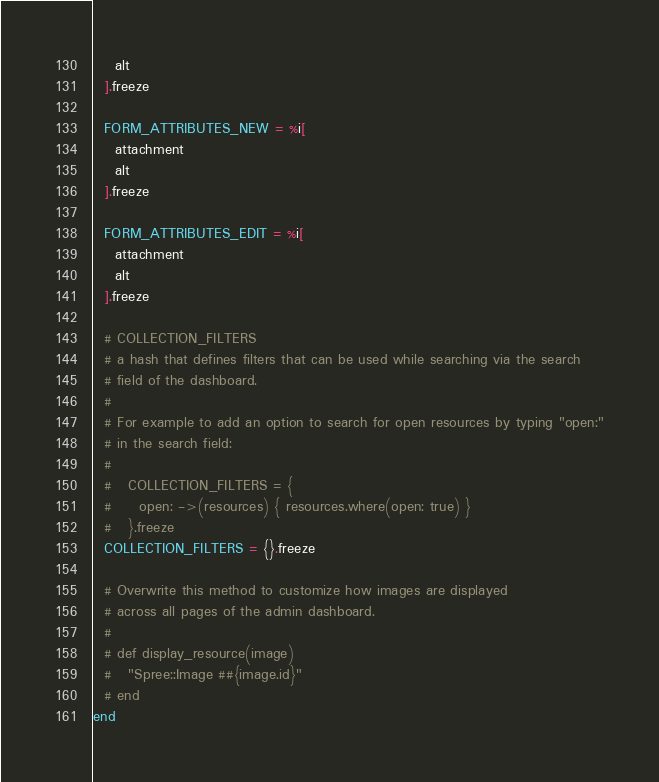Convert code to text. <code><loc_0><loc_0><loc_500><loc_500><_Ruby_>    alt
  ].freeze

  FORM_ATTRIBUTES_NEW = %i[
    attachment
    alt
  ].freeze

  FORM_ATTRIBUTES_EDIT = %i[
    attachment
    alt
  ].freeze

  # COLLECTION_FILTERS
  # a hash that defines filters that can be used while searching via the search
  # field of the dashboard.
  #
  # For example to add an option to search for open resources by typing "open:"
  # in the search field:
  #
  #   COLLECTION_FILTERS = {
  #     open: ->(resources) { resources.where(open: true) }
  #   }.freeze
  COLLECTION_FILTERS = {}.freeze

  # Overwrite this method to customize how images are displayed
  # across all pages of the admin dashboard.
  #
  # def display_resource(image)
  #   "Spree::Image ##{image.id}"
  # end
end
</code> 